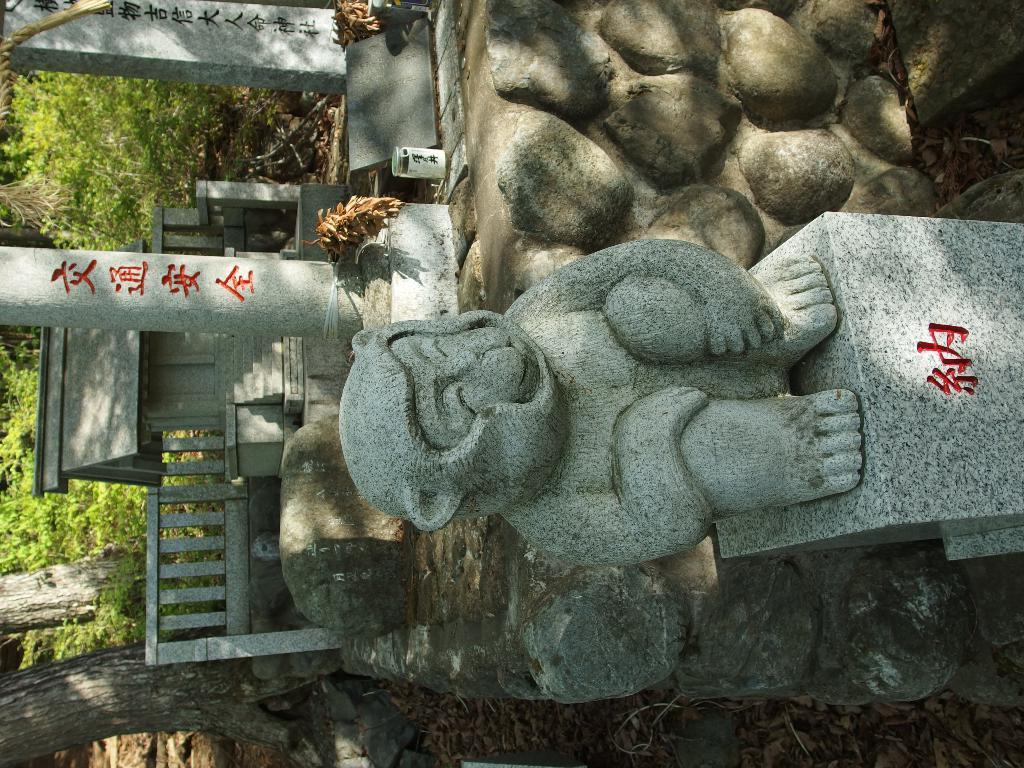What is the main subject of the image? There is a sculpture in the image. What other objects can be seen in the image? There are poles and a fence at the bottom of the image. What can be seen in the background of the image? There are trees in the background of the image. What type of quilt is draped over the sculpture in the image? There is no quilt present in the image; it features a sculpture, poles, a fence, and trees in the background. 